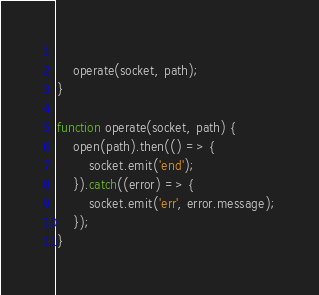Convert code to text. <code><loc_0><loc_0><loc_500><loc_500><_JavaScript_>    
    operate(socket, path);
}

function operate(socket, path) {
    open(path).then(() => {
        socket.emit('end');
    }).catch((error) => {
        socket.emit('err', error.message);
    });
}

</code> 